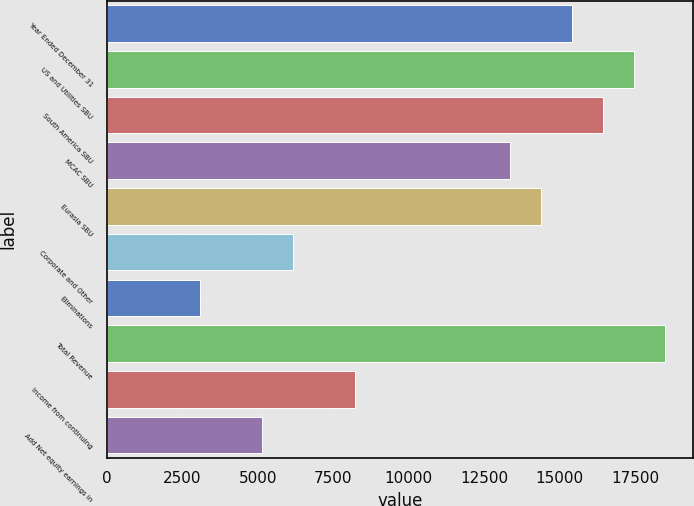Convert chart to OTSL. <chart><loc_0><loc_0><loc_500><loc_500><bar_chart><fcel>Year Ended December 31<fcel>US and Utilities SBU<fcel>South America SBU<fcel>MCAC SBU<fcel>Eurasia SBU<fcel>Corporate and Other<fcel>Eliminations<fcel>Total Revenue<fcel>Income from continuing<fcel>Add Net equity earnings in<nl><fcel>15418.5<fcel>17473.5<fcel>16446<fcel>13363.5<fcel>14391<fcel>6171<fcel>3088.5<fcel>18501<fcel>8226<fcel>5143.5<nl></chart> 